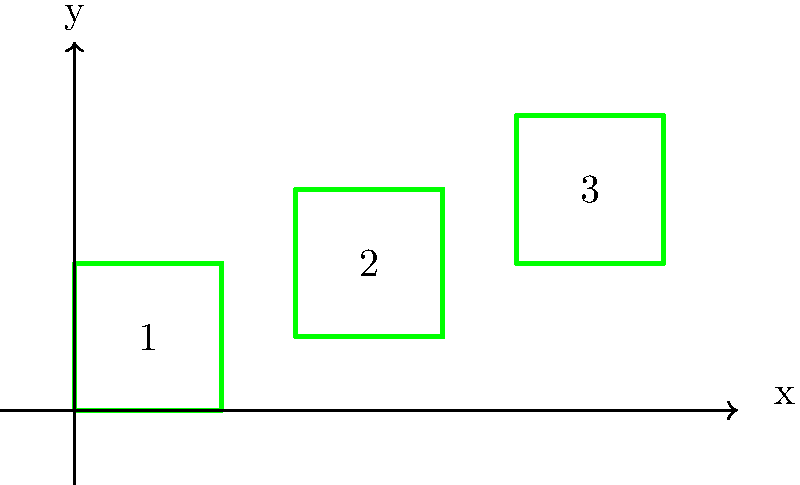To create an efficient maze pattern, you need to translate hedge shapes 1 and 2 to align with hedge shape 3. What is the translation vector $(a,b)$ needed to move hedge shape 1 to the position of hedge shape 3? To find the translation vector that moves hedge shape 1 to the position of hedge shape 3, we need to follow these steps:

1. Identify the coordinates of corresponding points in shapes 1 and 3:
   Shape 1: bottom-left corner at $(0,0)$
   Shape 3: bottom-left corner at $(6,2)$

2. Calculate the horizontal displacement (a):
   $a = 6 - 0 = 6$

3. Calculate the vertical displacement (b):
   $b = 2 - 0 = 2$

4. The translation vector is the combination of these displacements: $(a,b) = (6,2)$

This vector $(6,2)$ represents the movement required to shift hedge shape 1 to the position of hedge shape 3, which would create an efficient and consistent pattern for the maze.
Answer: $(6,2)$ 